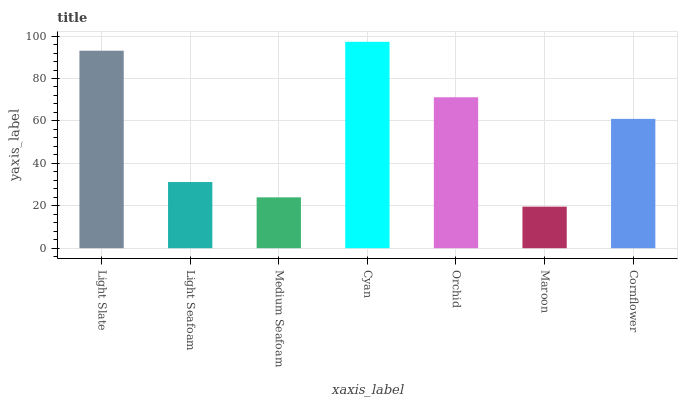Is Light Seafoam the minimum?
Answer yes or no. No. Is Light Seafoam the maximum?
Answer yes or no. No. Is Light Slate greater than Light Seafoam?
Answer yes or no. Yes. Is Light Seafoam less than Light Slate?
Answer yes or no. Yes. Is Light Seafoam greater than Light Slate?
Answer yes or no. No. Is Light Slate less than Light Seafoam?
Answer yes or no. No. Is Cornflower the high median?
Answer yes or no. Yes. Is Cornflower the low median?
Answer yes or no. Yes. Is Orchid the high median?
Answer yes or no. No. Is Light Slate the low median?
Answer yes or no. No. 